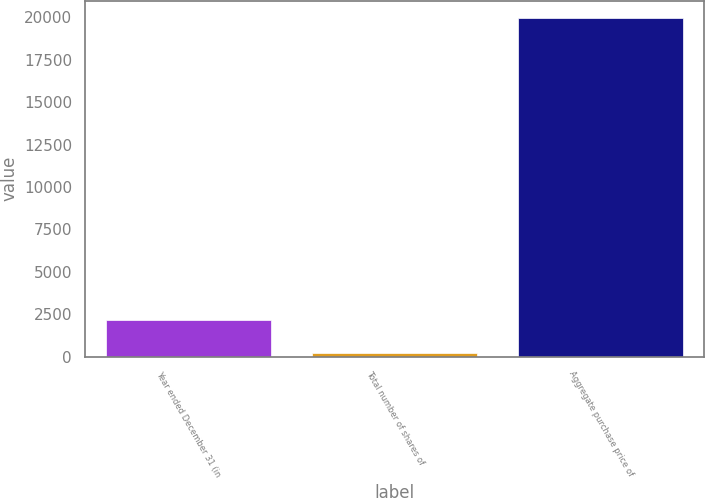Convert chart to OTSL. <chart><loc_0><loc_0><loc_500><loc_500><bar_chart><fcel>Year ended December 31 (in<fcel>Total number of shares of<fcel>Aggregate purchase price of<nl><fcel>2161.65<fcel>181.5<fcel>19983<nl></chart> 